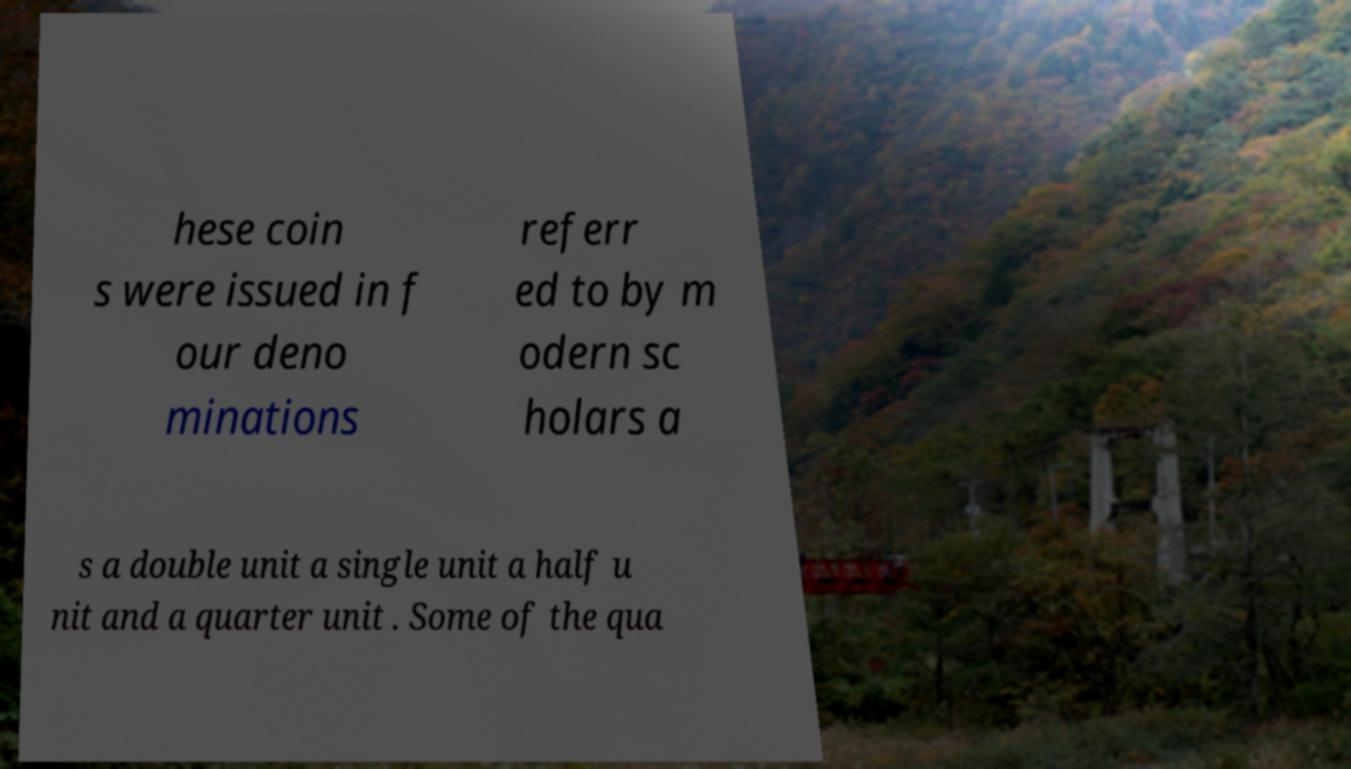Could you assist in decoding the text presented in this image and type it out clearly? hese coin s were issued in f our deno minations referr ed to by m odern sc holars a s a double unit a single unit a half u nit and a quarter unit . Some of the qua 